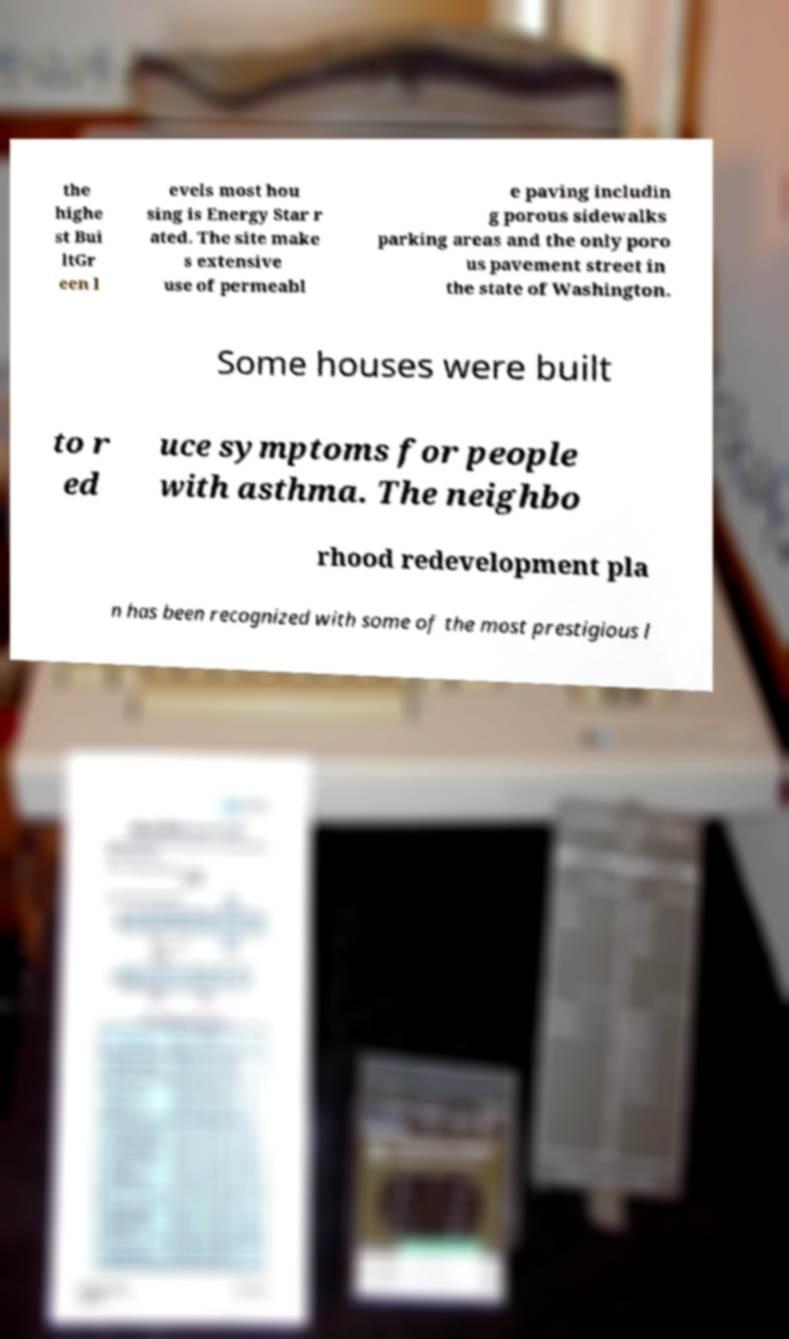There's text embedded in this image that I need extracted. Can you transcribe it verbatim? the highe st Bui ltGr een l evels most hou sing is Energy Star r ated. The site make s extensive use of permeabl e paving includin g porous sidewalks parking areas and the only poro us pavement street in the state of Washington. Some houses were built to r ed uce symptoms for people with asthma. The neighbo rhood redevelopment pla n has been recognized with some of the most prestigious l 